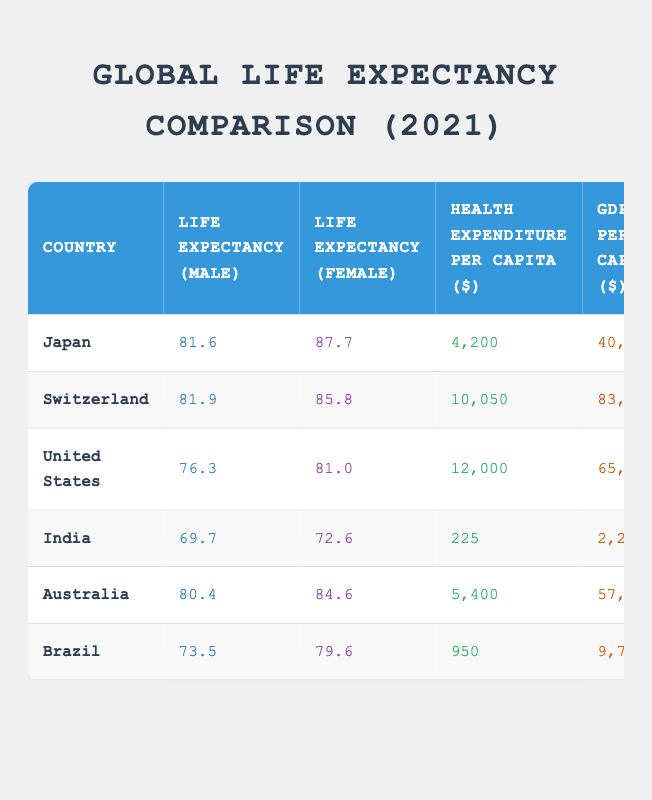What is the life expectancy for females in Japan? According to the table, the life expectancy for females in Japan is 87.7 years, which is directly stated in the row corresponding to Japan.
Answer: 87.7 Which country has the highest male life expectancy? From the table, Switzerland has the highest male life expectancy at 81.9 years, compared to the other countries listed.
Answer: 81.9 How much does health expenditure per capita in India differ from that in the United States? The health expenditure per capita in India is 225 dollars and in the United States it's 12,000 dollars. The difference is calculated as 12,000 - 225 = 11,775 dollars.
Answer: 11775 Is it true that Australia has a higher life expectancy for females than Brazil? The table shows that Australia's female life expectancy is 84.6 years while Brazil's is 79.6 years. Therefore, it is true that Australia has a higher female life expectancy.
Answer: Yes What is the average life expectancy for males among the countries listed? The average for males is calculated as (81.6 + 81.9 + 76.3 + 69.7 + 80.4 + 73.5) / 6 = 76.5 years, summing the life expectancy values and dividing by the number of countries.
Answer: 76.5 Which country has the lowest GDP per capita? Referring to the table, India has the lowest GDP per capita listed at 2,200 dollars, which can be directly noted from the corresponding row.
Answer: 2200 What is the life expectancy difference between females in Switzerland and males in the United States? The life expectancy for females in Switzerland is 85.8 years and for males in the United States, it is 76.3 years. The difference is 85.8 - 76.3 = 9.5 years.
Answer: 9.5 Which country spends the least on health expenditure per capita? The table specifies that India spends the least on health expenditure, which is 225 dollars. This is visible in the row for India, compared to the other countries.
Answer: 225 